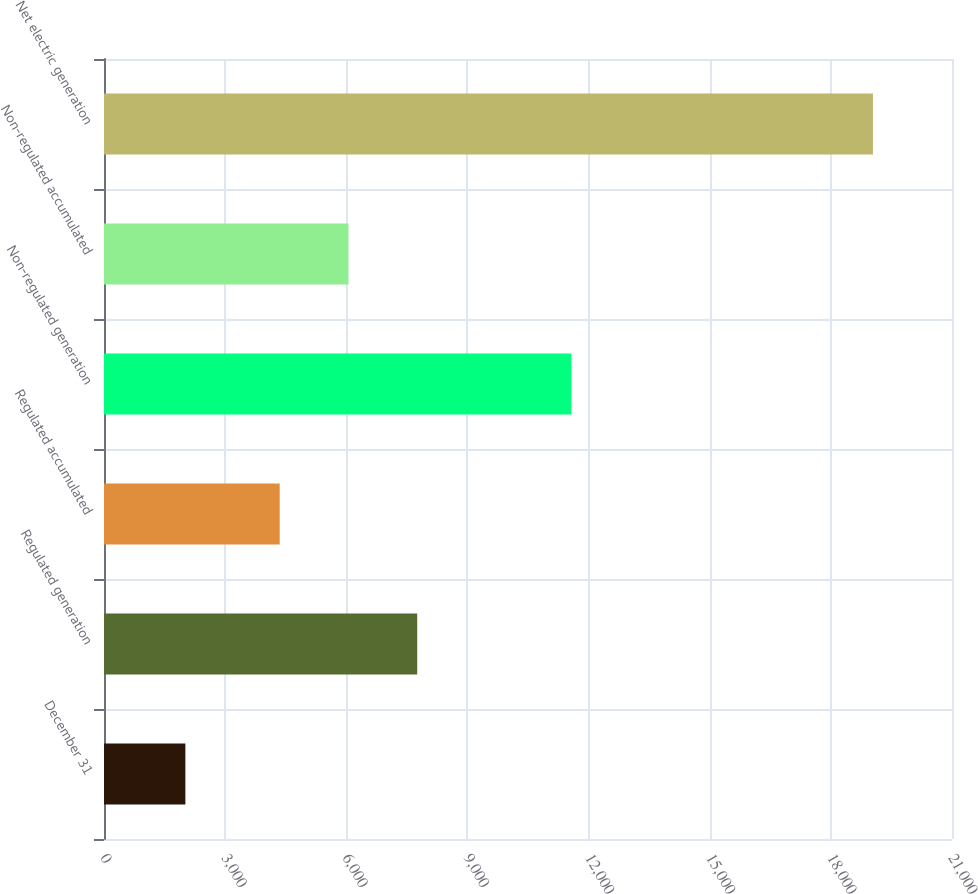<chart> <loc_0><loc_0><loc_500><loc_500><bar_chart><fcel>December 31<fcel>Regulated generation<fcel>Regulated accumulated<fcel>Non-regulated generation<fcel>Non-regulated accumulated<fcel>Net electric generation<nl><fcel>2015<fcel>7756.4<fcel>4351<fcel>11575<fcel>6053.7<fcel>19042<nl></chart> 